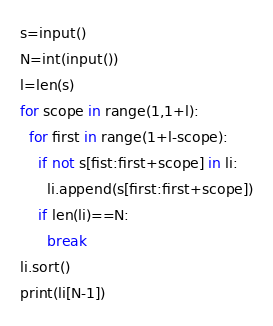Convert code to text. <code><loc_0><loc_0><loc_500><loc_500><_Python_>s=input()
N=int(input())
l=len(s)
for scope in range(1,1+l):
  for first in range(1+l-scope):
    if not s[fist:first+scope] in li:
      li.append(s[first:first+scope])
    if len(li)==N:
      break
li.sort()   
print(li[N-1])</code> 